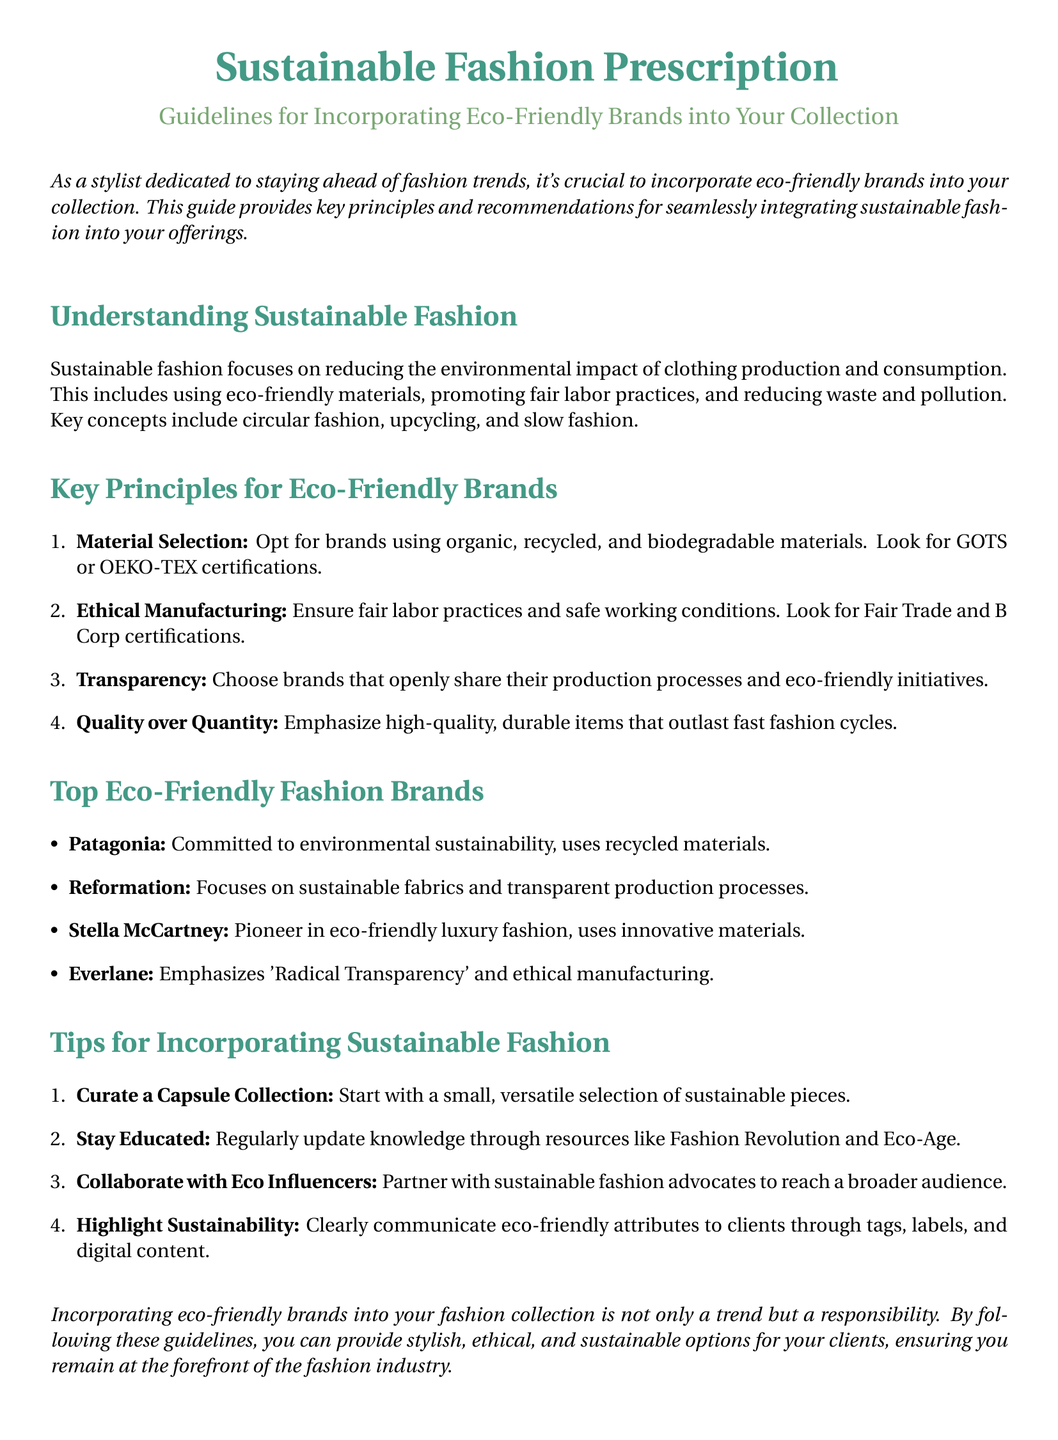what is the title of the document? The title is presented at the beginning of the document, which is "Sustainable Fashion Prescription."
Answer: Sustainable Fashion Prescription what is the subtitle of the document? The subtitle provides further context about the content, stated as "Guidelines for Incorporating Eco-Friendly Brands into Your Collection."
Answer: Guidelines for Incorporating Eco-Friendly Brands into Your Collection name one certification to look for in material selection. The document lists certifications to ensure material selection aligns with eco-friendly practices. One certification mentioned is GOTS.
Answer: GOTS what is one key principle for ethical manufacturing? The document outlines principles related to ethical manufacturing. One such principle emphasizes ensuring fair labor practices.
Answer: Fair labor practices which brand is a pioneer in eco-friendly luxury fashion? The document lists top eco-friendly brands and identifies a specific leader in luxury fashion sustainability.
Answer: Stella McCartney what is the first tip for incorporating sustainable fashion? The document provides practical tips, with the first being about starting with a curated selection.
Answer: Curate a Capsule Collection name a resource for staying educated on sustainable fashion. Mentioned in the document, resources are essential for keeping updated on sustainable trends. One resource is Fashion Revolution.
Answer: Fashion Revolution how many key principles for eco-friendly brands are mentioned? The document outlines specific key principles, and counting them reveals the total number of principles listed.
Answer: Four what does Everlane emphasize in their brand philosophy? The document highlights core aspects of Everlane’s approach to fashion, stating they focus on a specific value.
Answer: Radical Transparency 